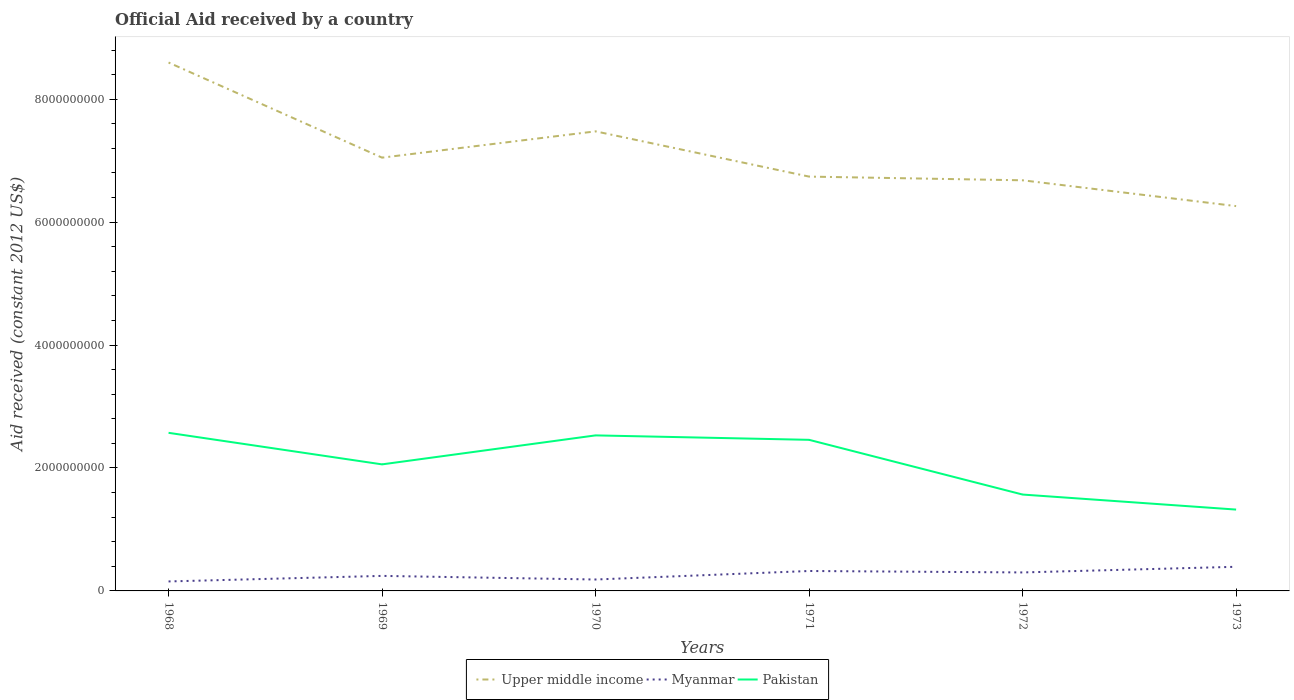Across all years, what is the maximum net official aid received in Myanmar?
Your response must be concise. 1.54e+08. What is the total net official aid received in Myanmar in the graph?
Offer a very short reply. 2.34e+07. What is the difference between the highest and the second highest net official aid received in Pakistan?
Your answer should be compact. 1.25e+09. How many lines are there?
Your answer should be very brief. 3. How many years are there in the graph?
Offer a terse response. 6. What is the difference between two consecutive major ticks on the Y-axis?
Ensure brevity in your answer.  2.00e+09. Does the graph contain any zero values?
Your answer should be compact. No. Does the graph contain grids?
Keep it short and to the point. No. How many legend labels are there?
Your answer should be compact. 3. How are the legend labels stacked?
Offer a very short reply. Horizontal. What is the title of the graph?
Your answer should be very brief. Official Aid received by a country. What is the label or title of the X-axis?
Provide a short and direct response. Years. What is the label or title of the Y-axis?
Give a very brief answer. Aid received (constant 2012 US$). What is the Aid received (constant 2012 US$) in Upper middle income in 1968?
Make the answer very short. 8.60e+09. What is the Aid received (constant 2012 US$) in Myanmar in 1968?
Provide a succinct answer. 1.54e+08. What is the Aid received (constant 2012 US$) in Pakistan in 1968?
Your response must be concise. 2.57e+09. What is the Aid received (constant 2012 US$) of Upper middle income in 1969?
Your response must be concise. 7.05e+09. What is the Aid received (constant 2012 US$) of Myanmar in 1969?
Keep it short and to the point. 2.45e+08. What is the Aid received (constant 2012 US$) of Pakistan in 1969?
Provide a short and direct response. 2.06e+09. What is the Aid received (constant 2012 US$) of Upper middle income in 1970?
Your answer should be very brief. 7.48e+09. What is the Aid received (constant 2012 US$) of Myanmar in 1970?
Provide a succinct answer. 1.86e+08. What is the Aid received (constant 2012 US$) in Pakistan in 1970?
Your response must be concise. 2.53e+09. What is the Aid received (constant 2012 US$) in Upper middle income in 1971?
Your answer should be very brief. 6.74e+09. What is the Aid received (constant 2012 US$) of Myanmar in 1971?
Offer a terse response. 3.24e+08. What is the Aid received (constant 2012 US$) of Pakistan in 1971?
Provide a short and direct response. 2.46e+09. What is the Aid received (constant 2012 US$) in Upper middle income in 1972?
Provide a short and direct response. 6.68e+09. What is the Aid received (constant 2012 US$) in Myanmar in 1972?
Provide a succinct answer. 3.01e+08. What is the Aid received (constant 2012 US$) of Pakistan in 1972?
Provide a short and direct response. 1.57e+09. What is the Aid received (constant 2012 US$) in Upper middle income in 1973?
Provide a short and direct response. 6.26e+09. What is the Aid received (constant 2012 US$) in Myanmar in 1973?
Your answer should be very brief. 3.93e+08. What is the Aid received (constant 2012 US$) in Pakistan in 1973?
Give a very brief answer. 1.32e+09. Across all years, what is the maximum Aid received (constant 2012 US$) of Upper middle income?
Give a very brief answer. 8.60e+09. Across all years, what is the maximum Aid received (constant 2012 US$) of Myanmar?
Your response must be concise. 3.93e+08. Across all years, what is the maximum Aid received (constant 2012 US$) in Pakistan?
Your response must be concise. 2.57e+09. Across all years, what is the minimum Aid received (constant 2012 US$) in Upper middle income?
Offer a terse response. 6.26e+09. Across all years, what is the minimum Aid received (constant 2012 US$) of Myanmar?
Provide a succinct answer. 1.54e+08. Across all years, what is the minimum Aid received (constant 2012 US$) of Pakistan?
Offer a terse response. 1.32e+09. What is the total Aid received (constant 2012 US$) in Upper middle income in the graph?
Offer a very short reply. 4.28e+1. What is the total Aid received (constant 2012 US$) in Myanmar in the graph?
Your response must be concise. 1.60e+09. What is the total Aid received (constant 2012 US$) in Pakistan in the graph?
Ensure brevity in your answer.  1.25e+1. What is the difference between the Aid received (constant 2012 US$) of Upper middle income in 1968 and that in 1969?
Your answer should be very brief. 1.55e+09. What is the difference between the Aid received (constant 2012 US$) in Myanmar in 1968 and that in 1969?
Your answer should be compact. -9.03e+07. What is the difference between the Aid received (constant 2012 US$) in Pakistan in 1968 and that in 1969?
Your answer should be very brief. 5.13e+08. What is the difference between the Aid received (constant 2012 US$) of Upper middle income in 1968 and that in 1970?
Your response must be concise. 1.12e+09. What is the difference between the Aid received (constant 2012 US$) of Myanmar in 1968 and that in 1970?
Keep it short and to the point. -3.14e+07. What is the difference between the Aid received (constant 2012 US$) of Pakistan in 1968 and that in 1970?
Provide a short and direct response. 4.18e+07. What is the difference between the Aid received (constant 2012 US$) of Upper middle income in 1968 and that in 1971?
Offer a terse response. 1.86e+09. What is the difference between the Aid received (constant 2012 US$) in Myanmar in 1968 and that in 1971?
Provide a short and direct response. -1.70e+08. What is the difference between the Aid received (constant 2012 US$) in Pakistan in 1968 and that in 1971?
Provide a short and direct response. 1.14e+08. What is the difference between the Aid received (constant 2012 US$) of Upper middle income in 1968 and that in 1972?
Make the answer very short. 1.92e+09. What is the difference between the Aid received (constant 2012 US$) of Myanmar in 1968 and that in 1972?
Your answer should be very brief. -1.46e+08. What is the difference between the Aid received (constant 2012 US$) of Pakistan in 1968 and that in 1972?
Offer a very short reply. 1.00e+09. What is the difference between the Aid received (constant 2012 US$) of Upper middle income in 1968 and that in 1973?
Make the answer very short. 2.34e+09. What is the difference between the Aid received (constant 2012 US$) in Myanmar in 1968 and that in 1973?
Ensure brevity in your answer.  -2.38e+08. What is the difference between the Aid received (constant 2012 US$) of Pakistan in 1968 and that in 1973?
Your answer should be compact. 1.25e+09. What is the difference between the Aid received (constant 2012 US$) of Upper middle income in 1969 and that in 1970?
Your answer should be compact. -4.28e+08. What is the difference between the Aid received (constant 2012 US$) of Myanmar in 1969 and that in 1970?
Provide a succinct answer. 5.89e+07. What is the difference between the Aid received (constant 2012 US$) in Pakistan in 1969 and that in 1970?
Offer a terse response. -4.72e+08. What is the difference between the Aid received (constant 2012 US$) in Upper middle income in 1969 and that in 1971?
Offer a terse response. 3.08e+08. What is the difference between the Aid received (constant 2012 US$) of Myanmar in 1969 and that in 1971?
Provide a succinct answer. -7.96e+07. What is the difference between the Aid received (constant 2012 US$) in Pakistan in 1969 and that in 1971?
Make the answer very short. -3.99e+08. What is the difference between the Aid received (constant 2012 US$) of Upper middle income in 1969 and that in 1972?
Keep it short and to the point. 3.69e+08. What is the difference between the Aid received (constant 2012 US$) of Myanmar in 1969 and that in 1972?
Ensure brevity in your answer.  -5.62e+07. What is the difference between the Aid received (constant 2012 US$) of Pakistan in 1969 and that in 1972?
Your answer should be compact. 4.91e+08. What is the difference between the Aid received (constant 2012 US$) of Upper middle income in 1969 and that in 1973?
Offer a terse response. 7.88e+08. What is the difference between the Aid received (constant 2012 US$) of Myanmar in 1969 and that in 1973?
Provide a short and direct response. -1.48e+08. What is the difference between the Aid received (constant 2012 US$) in Pakistan in 1969 and that in 1973?
Provide a succinct answer. 7.36e+08. What is the difference between the Aid received (constant 2012 US$) in Upper middle income in 1970 and that in 1971?
Give a very brief answer. 7.36e+08. What is the difference between the Aid received (constant 2012 US$) in Myanmar in 1970 and that in 1971?
Provide a short and direct response. -1.38e+08. What is the difference between the Aid received (constant 2012 US$) of Pakistan in 1970 and that in 1971?
Provide a succinct answer. 7.22e+07. What is the difference between the Aid received (constant 2012 US$) of Upper middle income in 1970 and that in 1972?
Make the answer very short. 7.96e+08. What is the difference between the Aid received (constant 2012 US$) in Myanmar in 1970 and that in 1972?
Your answer should be compact. -1.15e+08. What is the difference between the Aid received (constant 2012 US$) in Pakistan in 1970 and that in 1972?
Ensure brevity in your answer.  9.63e+08. What is the difference between the Aid received (constant 2012 US$) of Upper middle income in 1970 and that in 1973?
Give a very brief answer. 1.22e+09. What is the difference between the Aid received (constant 2012 US$) in Myanmar in 1970 and that in 1973?
Ensure brevity in your answer.  -2.07e+08. What is the difference between the Aid received (constant 2012 US$) of Pakistan in 1970 and that in 1973?
Your answer should be compact. 1.21e+09. What is the difference between the Aid received (constant 2012 US$) of Upper middle income in 1971 and that in 1972?
Make the answer very short. 6.02e+07. What is the difference between the Aid received (constant 2012 US$) in Myanmar in 1971 and that in 1972?
Offer a very short reply. 2.34e+07. What is the difference between the Aid received (constant 2012 US$) of Pakistan in 1971 and that in 1972?
Ensure brevity in your answer.  8.90e+08. What is the difference between the Aid received (constant 2012 US$) in Upper middle income in 1971 and that in 1973?
Give a very brief answer. 4.80e+08. What is the difference between the Aid received (constant 2012 US$) of Myanmar in 1971 and that in 1973?
Ensure brevity in your answer.  -6.85e+07. What is the difference between the Aid received (constant 2012 US$) of Pakistan in 1971 and that in 1973?
Give a very brief answer. 1.13e+09. What is the difference between the Aid received (constant 2012 US$) of Upper middle income in 1972 and that in 1973?
Offer a very short reply. 4.20e+08. What is the difference between the Aid received (constant 2012 US$) in Myanmar in 1972 and that in 1973?
Ensure brevity in your answer.  -9.20e+07. What is the difference between the Aid received (constant 2012 US$) in Pakistan in 1972 and that in 1973?
Your answer should be compact. 2.45e+08. What is the difference between the Aid received (constant 2012 US$) of Upper middle income in 1968 and the Aid received (constant 2012 US$) of Myanmar in 1969?
Your response must be concise. 8.35e+09. What is the difference between the Aid received (constant 2012 US$) of Upper middle income in 1968 and the Aid received (constant 2012 US$) of Pakistan in 1969?
Ensure brevity in your answer.  6.54e+09. What is the difference between the Aid received (constant 2012 US$) of Myanmar in 1968 and the Aid received (constant 2012 US$) of Pakistan in 1969?
Offer a very short reply. -1.90e+09. What is the difference between the Aid received (constant 2012 US$) of Upper middle income in 1968 and the Aid received (constant 2012 US$) of Myanmar in 1970?
Ensure brevity in your answer.  8.41e+09. What is the difference between the Aid received (constant 2012 US$) in Upper middle income in 1968 and the Aid received (constant 2012 US$) in Pakistan in 1970?
Your response must be concise. 6.07e+09. What is the difference between the Aid received (constant 2012 US$) in Myanmar in 1968 and the Aid received (constant 2012 US$) in Pakistan in 1970?
Ensure brevity in your answer.  -2.38e+09. What is the difference between the Aid received (constant 2012 US$) of Upper middle income in 1968 and the Aid received (constant 2012 US$) of Myanmar in 1971?
Your answer should be compact. 8.27e+09. What is the difference between the Aid received (constant 2012 US$) of Upper middle income in 1968 and the Aid received (constant 2012 US$) of Pakistan in 1971?
Your answer should be very brief. 6.14e+09. What is the difference between the Aid received (constant 2012 US$) in Myanmar in 1968 and the Aid received (constant 2012 US$) in Pakistan in 1971?
Your response must be concise. -2.30e+09. What is the difference between the Aid received (constant 2012 US$) of Upper middle income in 1968 and the Aid received (constant 2012 US$) of Myanmar in 1972?
Offer a very short reply. 8.30e+09. What is the difference between the Aid received (constant 2012 US$) in Upper middle income in 1968 and the Aid received (constant 2012 US$) in Pakistan in 1972?
Give a very brief answer. 7.03e+09. What is the difference between the Aid received (constant 2012 US$) in Myanmar in 1968 and the Aid received (constant 2012 US$) in Pakistan in 1972?
Keep it short and to the point. -1.41e+09. What is the difference between the Aid received (constant 2012 US$) of Upper middle income in 1968 and the Aid received (constant 2012 US$) of Myanmar in 1973?
Your answer should be very brief. 8.20e+09. What is the difference between the Aid received (constant 2012 US$) of Upper middle income in 1968 and the Aid received (constant 2012 US$) of Pakistan in 1973?
Ensure brevity in your answer.  7.27e+09. What is the difference between the Aid received (constant 2012 US$) of Myanmar in 1968 and the Aid received (constant 2012 US$) of Pakistan in 1973?
Give a very brief answer. -1.17e+09. What is the difference between the Aid received (constant 2012 US$) in Upper middle income in 1969 and the Aid received (constant 2012 US$) in Myanmar in 1970?
Provide a succinct answer. 6.86e+09. What is the difference between the Aid received (constant 2012 US$) in Upper middle income in 1969 and the Aid received (constant 2012 US$) in Pakistan in 1970?
Provide a short and direct response. 4.52e+09. What is the difference between the Aid received (constant 2012 US$) of Myanmar in 1969 and the Aid received (constant 2012 US$) of Pakistan in 1970?
Your answer should be very brief. -2.29e+09. What is the difference between the Aid received (constant 2012 US$) in Upper middle income in 1969 and the Aid received (constant 2012 US$) in Myanmar in 1971?
Provide a succinct answer. 6.73e+09. What is the difference between the Aid received (constant 2012 US$) of Upper middle income in 1969 and the Aid received (constant 2012 US$) of Pakistan in 1971?
Make the answer very short. 4.59e+09. What is the difference between the Aid received (constant 2012 US$) of Myanmar in 1969 and the Aid received (constant 2012 US$) of Pakistan in 1971?
Provide a short and direct response. -2.21e+09. What is the difference between the Aid received (constant 2012 US$) in Upper middle income in 1969 and the Aid received (constant 2012 US$) in Myanmar in 1972?
Ensure brevity in your answer.  6.75e+09. What is the difference between the Aid received (constant 2012 US$) of Upper middle income in 1969 and the Aid received (constant 2012 US$) of Pakistan in 1972?
Your answer should be very brief. 5.48e+09. What is the difference between the Aid received (constant 2012 US$) of Myanmar in 1969 and the Aid received (constant 2012 US$) of Pakistan in 1972?
Provide a succinct answer. -1.32e+09. What is the difference between the Aid received (constant 2012 US$) of Upper middle income in 1969 and the Aid received (constant 2012 US$) of Myanmar in 1973?
Ensure brevity in your answer.  6.66e+09. What is the difference between the Aid received (constant 2012 US$) of Upper middle income in 1969 and the Aid received (constant 2012 US$) of Pakistan in 1973?
Ensure brevity in your answer.  5.73e+09. What is the difference between the Aid received (constant 2012 US$) of Myanmar in 1969 and the Aid received (constant 2012 US$) of Pakistan in 1973?
Offer a very short reply. -1.08e+09. What is the difference between the Aid received (constant 2012 US$) in Upper middle income in 1970 and the Aid received (constant 2012 US$) in Myanmar in 1971?
Your answer should be very brief. 7.15e+09. What is the difference between the Aid received (constant 2012 US$) in Upper middle income in 1970 and the Aid received (constant 2012 US$) in Pakistan in 1971?
Your answer should be very brief. 5.02e+09. What is the difference between the Aid received (constant 2012 US$) of Myanmar in 1970 and the Aid received (constant 2012 US$) of Pakistan in 1971?
Your answer should be compact. -2.27e+09. What is the difference between the Aid received (constant 2012 US$) in Upper middle income in 1970 and the Aid received (constant 2012 US$) in Myanmar in 1972?
Offer a terse response. 7.18e+09. What is the difference between the Aid received (constant 2012 US$) in Upper middle income in 1970 and the Aid received (constant 2012 US$) in Pakistan in 1972?
Provide a succinct answer. 5.91e+09. What is the difference between the Aid received (constant 2012 US$) in Myanmar in 1970 and the Aid received (constant 2012 US$) in Pakistan in 1972?
Offer a terse response. -1.38e+09. What is the difference between the Aid received (constant 2012 US$) of Upper middle income in 1970 and the Aid received (constant 2012 US$) of Myanmar in 1973?
Make the answer very short. 7.08e+09. What is the difference between the Aid received (constant 2012 US$) of Upper middle income in 1970 and the Aid received (constant 2012 US$) of Pakistan in 1973?
Your response must be concise. 6.15e+09. What is the difference between the Aid received (constant 2012 US$) in Myanmar in 1970 and the Aid received (constant 2012 US$) in Pakistan in 1973?
Keep it short and to the point. -1.14e+09. What is the difference between the Aid received (constant 2012 US$) in Upper middle income in 1971 and the Aid received (constant 2012 US$) in Myanmar in 1972?
Provide a short and direct response. 6.44e+09. What is the difference between the Aid received (constant 2012 US$) of Upper middle income in 1971 and the Aid received (constant 2012 US$) of Pakistan in 1972?
Your answer should be very brief. 5.17e+09. What is the difference between the Aid received (constant 2012 US$) of Myanmar in 1971 and the Aid received (constant 2012 US$) of Pakistan in 1972?
Your answer should be compact. -1.24e+09. What is the difference between the Aid received (constant 2012 US$) in Upper middle income in 1971 and the Aid received (constant 2012 US$) in Myanmar in 1973?
Provide a succinct answer. 6.35e+09. What is the difference between the Aid received (constant 2012 US$) of Upper middle income in 1971 and the Aid received (constant 2012 US$) of Pakistan in 1973?
Offer a very short reply. 5.42e+09. What is the difference between the Aid received (constant 2012 US$) of Myanmar in 1971 and the Aid received (constant 2012 US$) of Pakistan in 1973?
Give a very brief answer. -9.99e+08. What is the difference between the Aid received (constant 2012 US$) of Upper middle income in 1972 and the Aid received (constant 2012 US$) of Myanmar in 1973?
Your response must be concise. 6.29e+09. What is the difference between the Aid received (constant 2012 US$) of Upper middle income in 1972 and the Aid received (constant 2012 US$) of Pakistan in 1973?
Ensure brevity in your answer.  5.36e+09. What is the difference between the Aid received (constant 2012 US$) of Myanmar in 1972 and the Aid received (constant 2012 US$) of Pakistan in 1973?
Offer a very short reply. -1.02e+09. What is the average Aid received (constant 2012 US$) in Upper middle income per year?
Provide a succinct answer. 7.13e+09. What is the average Aid received (constant 2012 US$) in Myanmar per year?
Your response must be concise. 2.67e+08. What is the average Aid received (constant 2012 US$) of Pakistan per year?
Your answer should be compact. 2.09e+09. In the year 1968, what is the difference between the Aid received (constant 2012 US$) in Upper middle income and Aid received (constant 2012 US$) in Myanmar?
Offer a terse response. 8.44e+09. In the year 1968, what is the difference between the Aid received (constant 2012 US$) in Upper middle income and Aid received (constant 2012 US$) in Pakistan?
Keep it short and to the point. 6.02e+09. In the year 1968, what is the difference between the Aid received (constant 2012 US$) in Myanmar and Aid received (constant 2012 US$) in Pakistan?
Your response must be concise. -2.42e+09. In the year 1969, what is the difference between the Aid received (constant 2012 US$) in Upper middle income and Aid received (constant 2012 US$) in Myanmar?
Keep it short and to the point. 6.80e+09. In the year 1969, what is the difference between the Aid received (constant 2012 US$) in Upper middle income and Aid received (constant 2012 US$) in Pakistan?
Offer a very short reply. 4.99e+09. In the year 1969, what is the difference between the Aid received (constant 2012 US$) in Myanmar and Aid received (constant 2012 US$) in Pakistan?
Your answer should be compact. -1.81e+09. In the year 1970, what is the difference between the Aid received (constant 2012 US$) of Upper middle income and Aid received (constant 2012 US$) of Myanmar?
Ensure brevity in your answer.  7.29e+09. In the year 1970, what is the difference between the Aid received (constant 2012 US$) of Upper middle income and Aid received (constant 2012 US$) of Pakistan?
Ensure brevity in your answer.  4.95e+09. In the year 1970, what is the difference between the Aid received (constant 2012 US$) in Myanmar and Aid received (constant 2012 US$) in Pakistan?
Your response must be concise. -2.34e+09. In the year 1971, what is the difference between the Aid received (constant 2012 US$) in Upper middle income and Aid received (constant 2012 US$) in Myanmar?
Offer a terse response. 6.42e+09. In the year 1971, what is the difference between the Aid received (constant 2012 US$) in Upper middle income and Aid received (constant 2012 US$) in Pakistan?
Your response must be concise. 4.28e+09. In the year 1971, what is the difference between the Aid received (constant 2012 US$) in Myanmar and Aid received (constant 2012 US$) in Pakistan?
Keep it short and to the point. -2.13e+09. In the year 1972, what is the difference between the Aid received (constant 2012 US$) of Upper middle income and Aid received (constant 2012 US$) of Myanmar?
Give a very brief answer. 6.38e+09. In the year 1972, what is the difference between the Aid received (constant 2012 US$) in Upper middle income and Aid received (constant 2012 US$) in Pakistan?
Your response must be concise. 5.11e+09. In the year 1972, what is the difference between the Aid received (constant 2012 US$) of Myanmar and Aid received (constant 2012 US$) of Pakistan?
Give a very brief answer. -1.27e+09. In the year 1973, what is the difference between the Aid received (constant 2012 US$) in Upper middle income and Aid received (constant 2012 US$) in Myanmar?
Offer a terse response. 5.87e+09. In the year 1973, what is the difference between the Aid received (constant 2012 US$) in Upper middle income and Aid received (constant 2012 US$) in Pakistan?
Give a very brief answer. 4.94e+09. In the year 1973, what is the difference between the Aid received (constant 2012 US$) of Myanmar and Aid received (constant 2012 US$) of Pakistan?
Ensure brevity in your answer.  -9.31e+08. What is the ratio of the Aid received (constant 2012 US$) of Upper middle income in 1968 to that in 1969?
Provide a succinct answer. 1.22. What is the ratio of the Aid received (constant 2012 US$) of Myanmar in 1968 to that in 1969?
Your answer should be very brief. 0.63. What is the ratio of the Aid received (constant 2012 US$) in Pakistan in 1968 to that in 1969?
Provide a succinct answer. 1.25. What is the ratio of the Aid received (constant 2012 US$) in Upper middle income in 1968 to that in 1970?
Keep it short and to the point. 1.15. What is the ratio of the Aid received (constant 2012 US$) in Myanmar in 1968 to that in 1970?
Keep it short and to the point. 0.83. What is the ratio of the Aid received (constant 2012 US$) in Pakistan in 1968 to that in 1970?
Ensure brevity in your answer.  1.02. What is the ratio of the Aid received (constant 2012 US$) of Upper middle income in 1968 to that in 1971?
Your response must be concise. 1.28. What is the ratio of the Aid received (constant 2012 US$) in Myanmar in 1968 to that in 1971?
Keep it short and to the point. 0.48. What is the ratio of the Aid received (constant 2012 US$) in Pakistan in 1968 to that in 1971?
Offer a very short reply. 1.05. What is the ratio of the Aid received (constant 2012 US$) of Upper middle income in 1968 to that in 1972?
Ensure brevity in your answer.  1.29. What is the ratio of the Aid received (constant 2012 US$) of Myanmar in 1968 to that in 1972?
Keep it short and to the point. 0.51. What is the ratio of the Aid received (constant 2012 US$) in Pakistan in 1968 to that in 1972?
Your answer should be very brief. 1.64. What is the ratio of the Aid received (constant 2012 US$) in Upper middle income in 1968 to that in 1973?
Give a very brief answer. 1.37. What is the ratio of the Aid received (constant 2012 US$) in Myanmar in 1968 to that in 1973?
Give a very brief answer. 0.39. What is the ratio of the Aid received (constant 2012 US$) in Pakistan in 1968 to that in 1973?
Provide a short and direct response. 1.94. What is the ratio of the Aid received (constant 2012 US$) in Upper middle income in 1969 to that in 1970?
Your answer should be compact. 0.94. What is the ratio of the Aid received (constant 2012 US$) of Myanmar in 1969 to that in 1970?
Your answer should be compact. 1.32. What is the ratio of the Aid received (constant 2012 US$) in Pakistan in 1969 to that in 1970?
Your answer should be very brief. 0.81. What is the ratio of the Aid received (constant 2012 US$) in Upper middle income in 1969 to that in 1971?
Offer a terse response. 1.05. What is the ratio of the Aid received (constant 2012 US$) in Myanmar in 1969 to that in 1971?
Make the answer very short. 0.75. What is the ratio of the Aid received (constant 2012 US$) of Pakistan in 1969 to that in 1971?
Keep it short and to the point. 0.84. What is the ratio of the Aid received (constant 2012 US$) in Upper middle income in 1969 to that in 1972?
Offer a terse response. 1.06. What is the ratio of the Aid received (constant 2012 US$) in Myanmar in 1969 to that in 1972?
Ensure brevity in your answer.  0.81. What is the ratio of the Aid received (constant 2012 US$) of Pakistan in 1969 to that in 1972?
Make the answer very short. 1.31. What is the ratio of the Aid received (constant 2012 US$) of Upper middle income in 1969 to that in 1973?
Provide a short and direct response. 1.13. What is the ratio of the Aid received (constant 2012 US$) of Myanmar in 1969 to that in 1973?
Offer a very short reply. 0.62. What is the ratio of the Aid received (constant 2012 US$) in Pakistan in 1969 to that in 1973?
Provide a short and direct response. 1.56. What is the ratio of the Aid received (constant 2012 US$) in Upper middle income in 1970 to that in 1971?
Provide a short and direct response. 1.11. What is the ratio of the Aid received (constant 2012 US$) in Myanmar in 1970 to that in 1971?
Offer a very short reply. 0.57. What is the ratio of the Aid received (constant 2012 US$) in Pakistan in 1970 to that in 1971?
Ensure brevity in your answer.  1.03. What is the ratio of the Aid received (constant 2012 US$) in Upper middle income in 1970 to that in 1972?
Offer a very short reply. 1.12. What is the ratio of the Aid received (constant 2012 US$) of Myanmar in 1970 to that in 1972?
Your answer should be compact. 0.62. What is the ratio of the Aid received (constant 2012 US$) of Pakistan in 1970 to that in 1972?
Offer a terse response. 1.61. What is the ratio of the Aid received (constant 2012 US$) in Upper middle income in 1970 to that in 1973?
Make the answer very short. 1.19. What is the ratio of the Aid received (constant 2012 US$) in Myanmar in 1970 to that in 1973?
Make the answer very short. 0.47. What is the ratio of the Aid received (constant 2012 US$) in Pakistan in 1970 to that in 1973?
Provide a succinct answer. 1.91. What is the ratio of the Aid received (constant 2012 US$) in Upper middle income in 1971 to that in 1972?
Keep it short and to the point. 1.01. What is the ratio of the Aid received (constant 2012 US$) in Myanmar in 1971 to that in 1972?
Your response must be concise. 1.08. What is the ratio of the Aid received (constant 2012 US$) in Pakistan in 1971 to that in 1972?
Offer a terse response. 1.57. What is the ratio of the Aid received (constant 2012 US$) of Upper middle income in 1971 to that in 1973?
Offer a terse response. 1.08. What is the ratio of the Aid received (constant 2012 US$) in Myanmar in 1971 to that in 1973?
Your answer should be very brief. 0.83. What is the ratio of the Aid received (constant 2012 US$) in Pakistan in 1971 to that in 1973?
Give a very brief answer. 1.86. What is the ratio of the Aid received (constant 2012 US$) in Upper middle income in 1972 to that in 1973?
Offer a very short reply. 1.07. What is the ratio of the Aid received (constant 2012 US$) in Myanmar in 1972 to that in 1973?
Make the answer very short. 0.77. What is the ratio of the Aid received (constant 2012 US$) of Pakistan in 1972 to that in 1973?
Your answer should be very brief. 1.18. What is the difference between the highest and the second highest Aid received (constant 2012 US$) of Upper middle income?
Provide a short and direct response. 1.12e+09. What is the difference between the highest and the second highest Aid received (constant 2012 US$) in Myanmar?
Your answer should be very brief. 6.85e+07. What is the difference between the highest and the second highest Aid received (constant 2012 US$) in Pakistan?
Make the answer very short. 4.18e+07. What is the difference between the highest and the lowest Aid received (constant 2012 US$) in Upper middle income?
Your response must be concise. 2.34e+09. What is the difference between the highest and the lowest Aid received (constant 2012 US$) of Myanmar?
Ensure brevity in your answer.  2.38e+08. What is the difference between the highest and the lowest Aid received (constant 2012 US$) in Pakistan?
Give a very brief answer. 1.25e+09. 